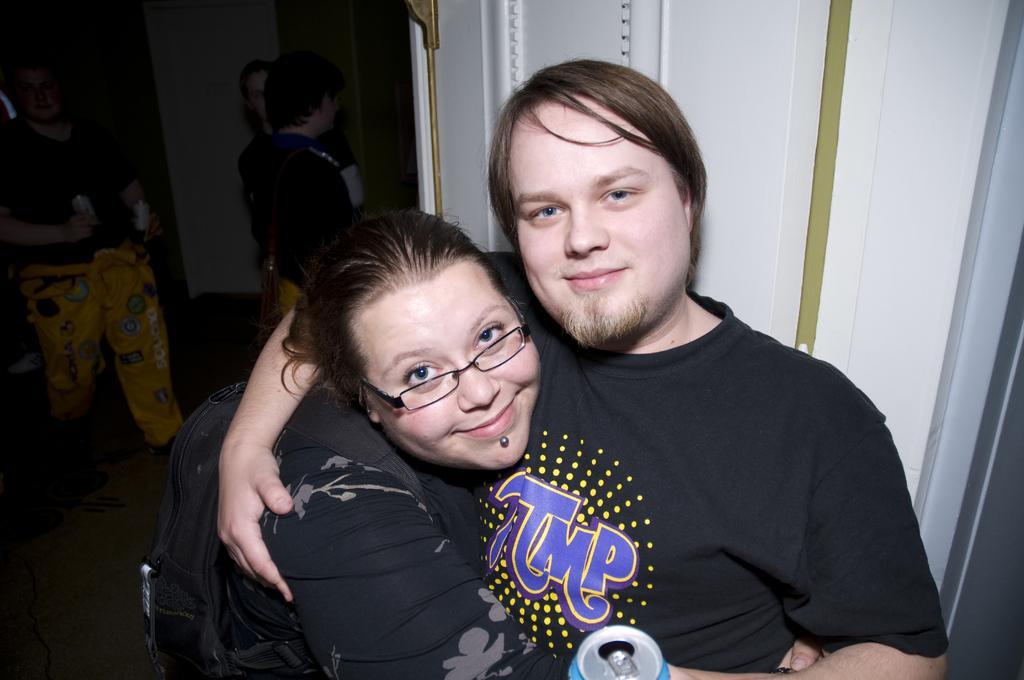Can you describe this image briefly? In the center of the image two persons are there, one person is holding a coke bottle and another person is carrying a bag. In the background of the image we can see wall and some persons are there. At the bottom of the image floor is there. 